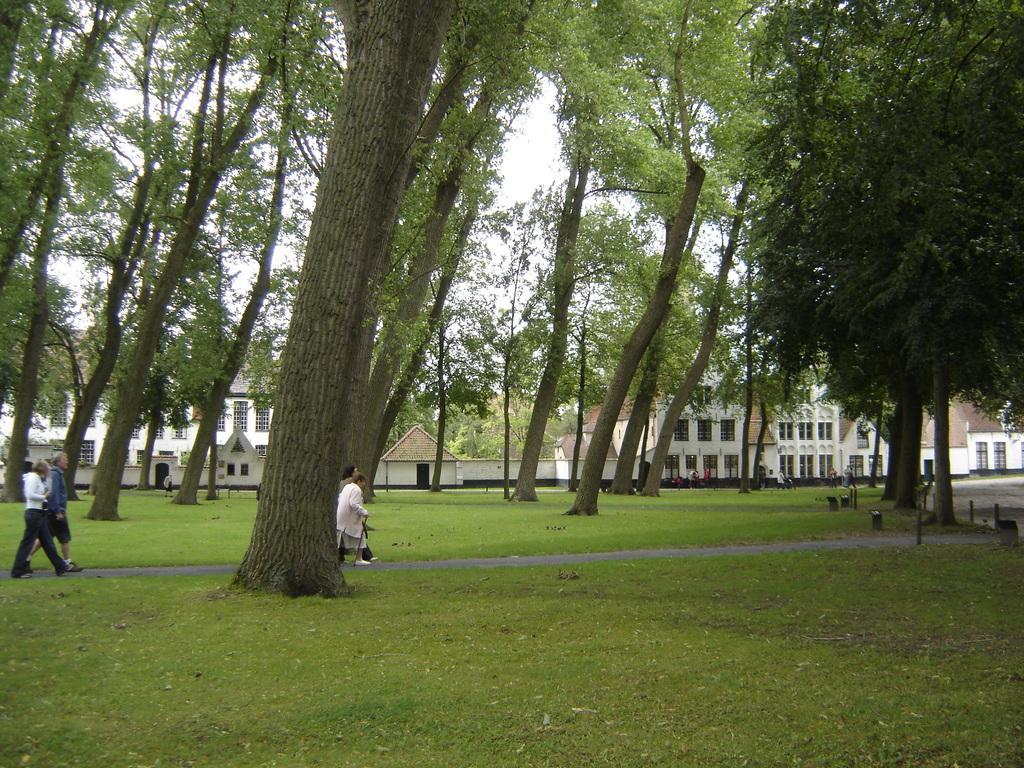In one or two sentences, can you explain what this image depicts? In this picture we can see grass at the bottom, there are some trees in the middle, we can see some people walking on the left side, in the background there are some buildings, we can see the sky at the top of the picture. 